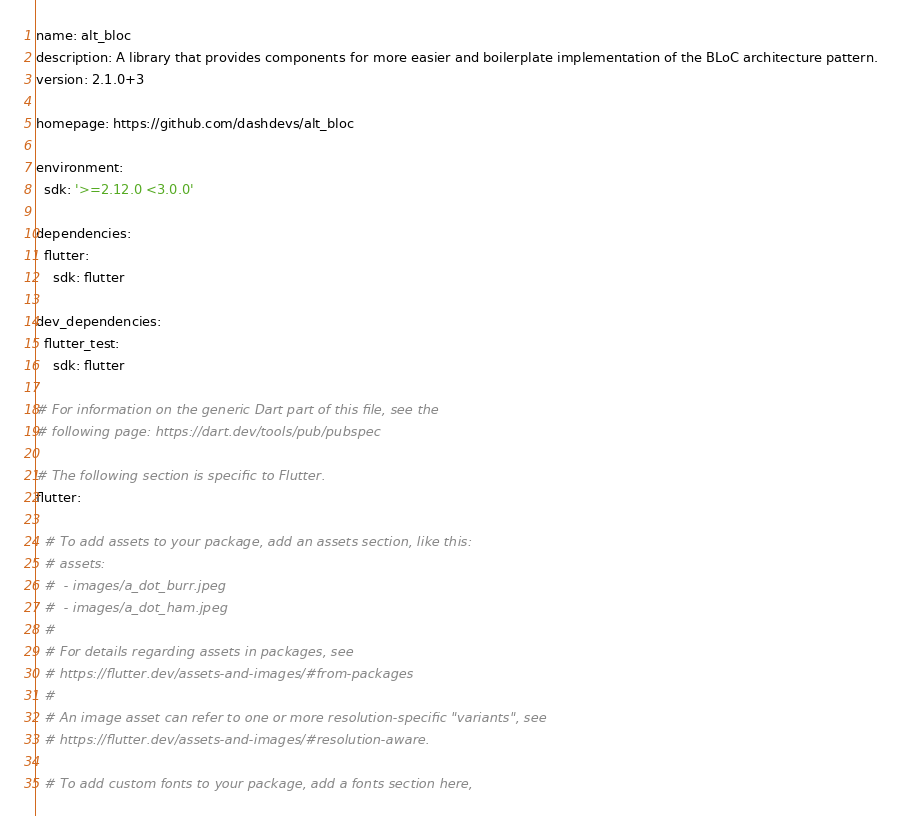<code> <loc_0><loc_0><loc_500><loc_500><_YAML_>name: alt_bloc
description: A library that provides components for more easier and boilerplate implementation of the BLoC architecture pattern.
version: 2.1.0+3

homepage: https://github.com/dashdevs/alt_bloc

environment:
  sdk: '>=2.12.0 <3.0.0'

dependencies:
  flutter:
    sdk: flutter

dev_dependencies:
  flutter_test:
    sdk: flutter

# For information on the generic Dart part of this file, see the
# following page: https://dart.dev/tools/pub/pubspec

# The following section is specific to Flutter.
flutter:

  # To add assets to your package, add an assets section, like this:
  # assets:
  #  - images/a_dot_burr.jpeg
  #  - images/a_dot_ham.jpeg
  #
  # For details regarding assets in packages, see
  # https://flutter.dev/assets-and-images/#from-packages
  #
  # An image asset can refer to one or more resolution-specific "variants", see
  # https://flutter.dev/assets-and-images/#resolution-aware.

  # To add custom fonts to your package, add a fonts section here,</code> 